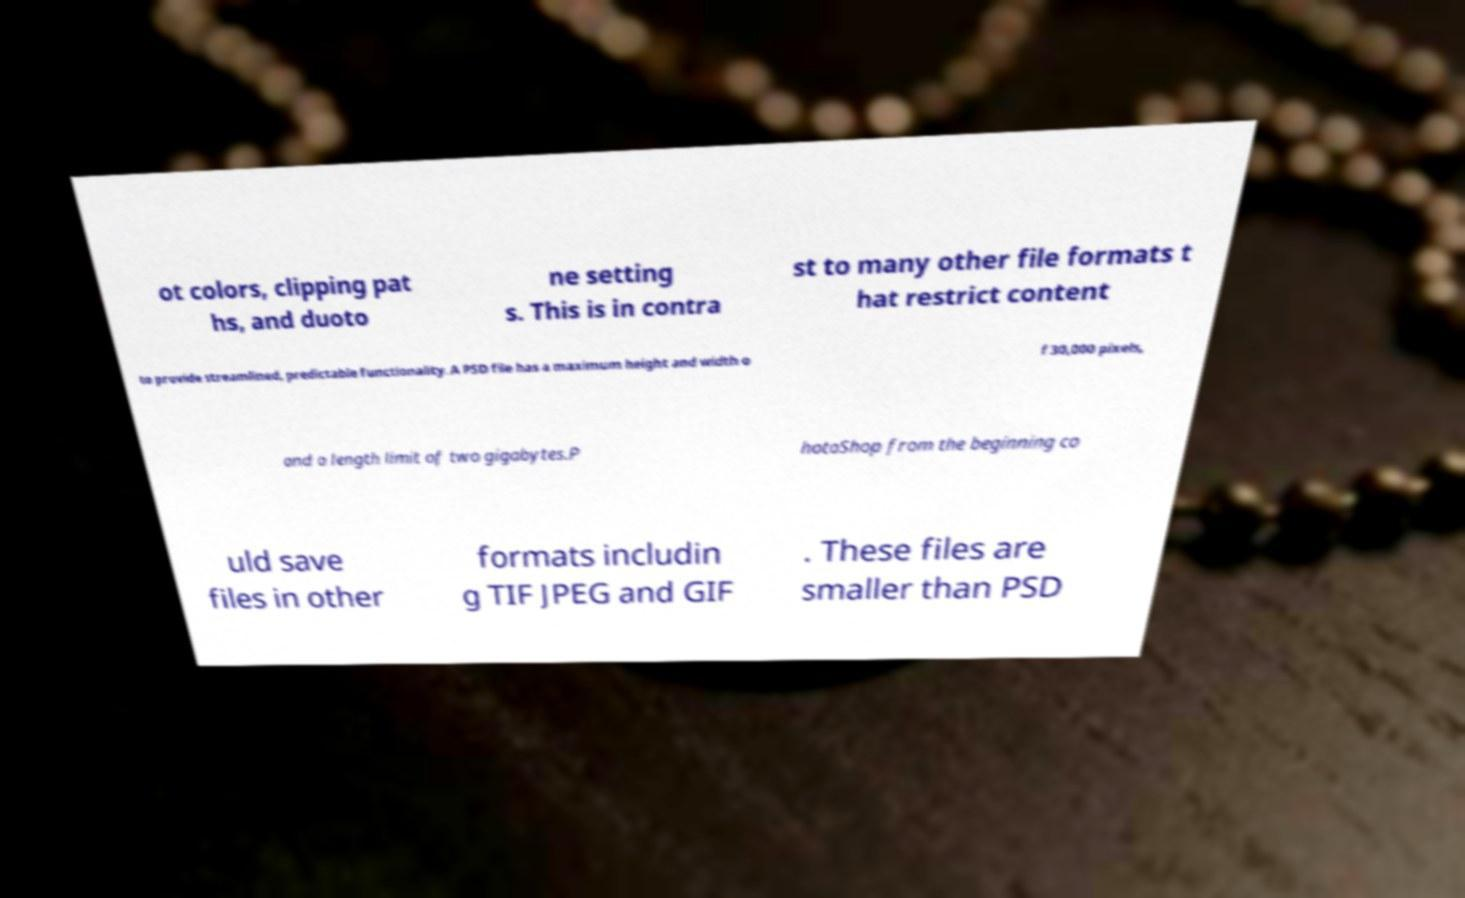Can you accurately transcribe the text from the provided image for me? ot colors, clipping pat hs, and duoto ne setting s. This is in contra st to many other file formats t hat restrict content to provide streamlined, predictable functionality. A PSD file has a maximum height and width o f 30,000 pixels, and a length limit of two gigabytes.P hotoShop from the beginning co uld save files in other formats includin g TIF JPEG and GIF . These files are smaller than PSD 